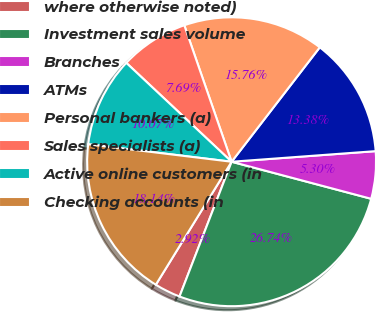Convert chart. <chart><loc_0><loc_0><loc_500><loc_500><pie_chart><fcel>where otherwise noted)<fcel>Investment sales volume<fcel>Branches<fcel>ATMs<fcel>Personal bankers (a)<fcel>Sales specialists (a)<fcel>Active online customers (in<fcel>Checking accounts (in<nl><fcel>2.92%<fcel>26.74%<fcel>5.3%<fcel>13.38%<fcel>15.76%<fcel>7.69%<fcel>10.07%<fcel>18.14%<nl></chart> 